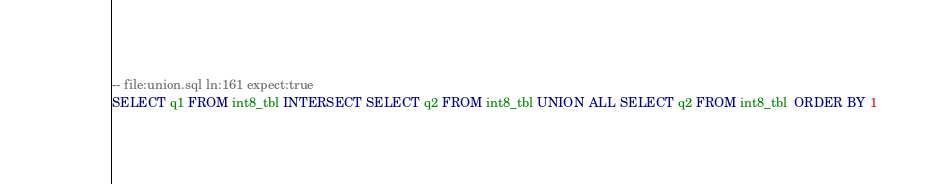Convert code to text. <code><loc_0><loc_0><loc_500><loc_500><_SQL_>-- file:union.sql ln:161 expect:true
SELECT q1 FROM int8_tbl INTERSECT SELECT q2 FROM int8_tbl UNION ALL SELECT q2 FROM int8_tbl  ORDER BY 1
</code> 